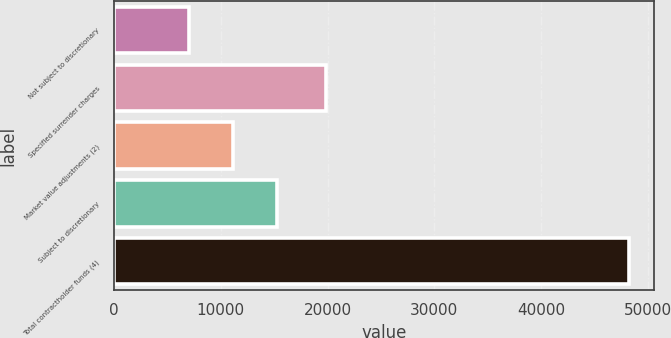Convert chart. <chart><loc_0><loc_0><loc_500><loc_500><bar_chart><fcel>Not subject to discretionary<fcel>Specified surrender charges<fcel>Market value adjustments (2)<fcel>Subject to discretionary<fcel>Total contractholder funds (4)<nl><fcel>6998<fcel>19815<fcel>11117.7<fcel>15237.4<fcel>48195<nl></chart> 